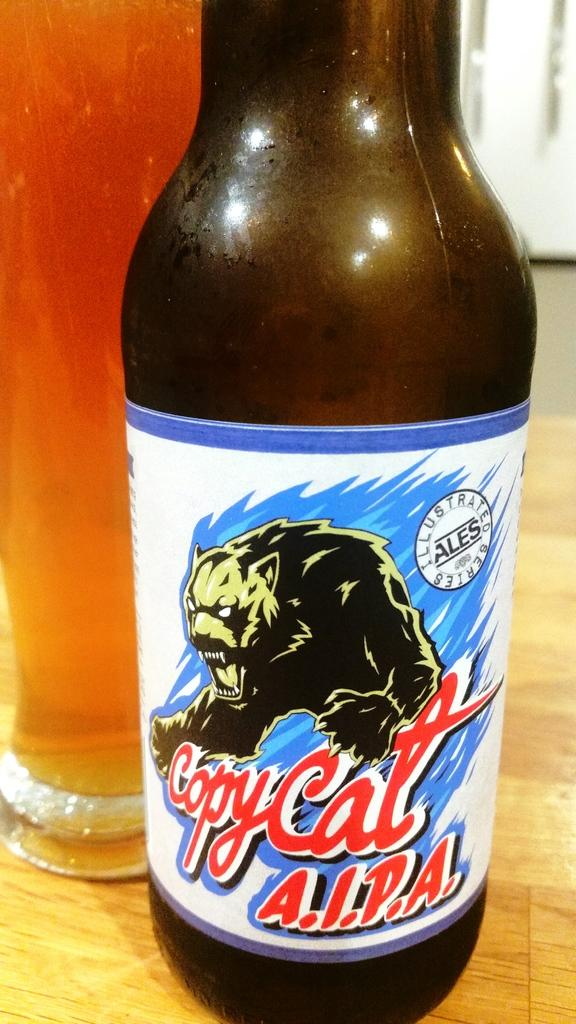<image>
Present a compact description of the photo's key features. A bottle of Copy Cat A.I.P.A. beer is next to a poured glass of beer on the counter. 